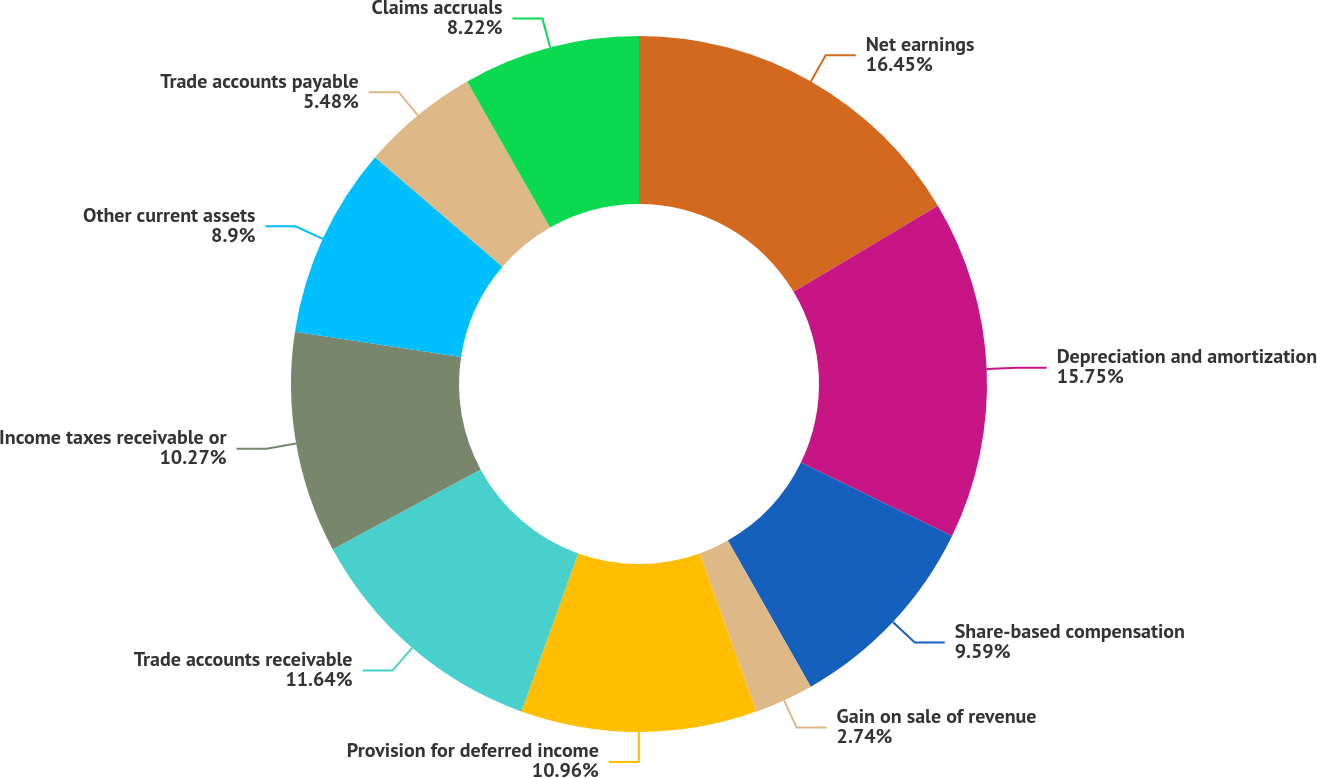Convert chart to OTSL. <chart><loc_0><loc_0><loc_500><loc_500><pie_chart><fcel>Net earnings<fcel>Depreciation and amortization<fcel>Share-based compensation<fcel>Gain on sale of revenue<fcel>Provision for deferred income<fcel>Trade accounts receivable<fcel>Income taxes receivable or<fcel>Other current assets<fcel>Trade accounts payable<fcel>Claims accruals<nl><fcel>16.44%<fcel>15.75%<fcel>9.59%<fcel>2.74%<fcel>10.96%<fcel>11.64%<fcel>10.27%<fcel>8.9%<fcel>5.48%<fcel>8.22%<nl></chart> 